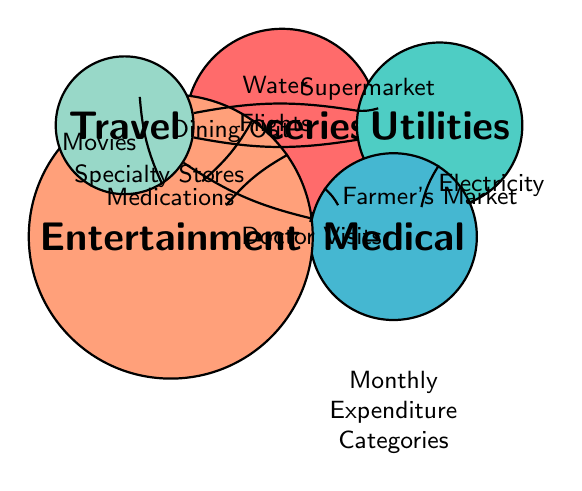What is the main category associated with the subcategory "Doctor Visits"? The subcategory "Doctor Visits" falls under the main category "Medical Expenses". This is evident from the initial structure of the diagram where "Medical Expenses" is positioned adjacent to "Groceries" and visually connected through the edge labeled "Doctor Visits".
Answer: Medical Expenses How many subcategories are listed under "Utilities"? The main category "Utilities" has four subcategories: "Electricity", "Water", "Internet", and "Gas". Counting these subcategories directly from the diagram confirms their total.
Answer: 4 What is the connection between "Entertainment" and "Travel"? There is no direct connection between "Entertainment" and "Travel" in the diagram. Each of these categories is only linked to others without a direct edge connecting them.
Answer: None Which subcategory is associated with "Groceries" that connects to "Medical Expenses"? The subcategory "Farmer's Market" connects "Groceries" to "Medical Expenses". The edge between them is labeled accordingly, indicating a flow from "Groceries" to "Medical Expenses".
Answer: Farmer's Market What is the total number of main categories displayed in the diagram? The diagram includes five main categories: "Groceries", "Utilities", "Medical Expenses", "Entertainment", and "Travel". Each is represented as a distinct node, confirming their total number as five.
Answer: 5 Which category has a direct connection to both "Entertainment" and "Utilities"? The category "Medical Expenses" has direct connections to both "Entertainment" through "Doctor Visits" and "Utilities" through "Electricity". This can be traced through the edges leading from "Medical Expenses" to both categories.
Answer: Medical Expenses List all the subcategories under "Entertainment". The subcategories under "Entertainment" are "Movies", "Concerts", "Dining Out", and "Subscriptions (e.g., Netflix)". These are directly connected to "Entertainment" in the diagram, indicating their relationship.
Answer: Movies, Concerts, Dining Out, Subscriptions (e.g., Netflix) 